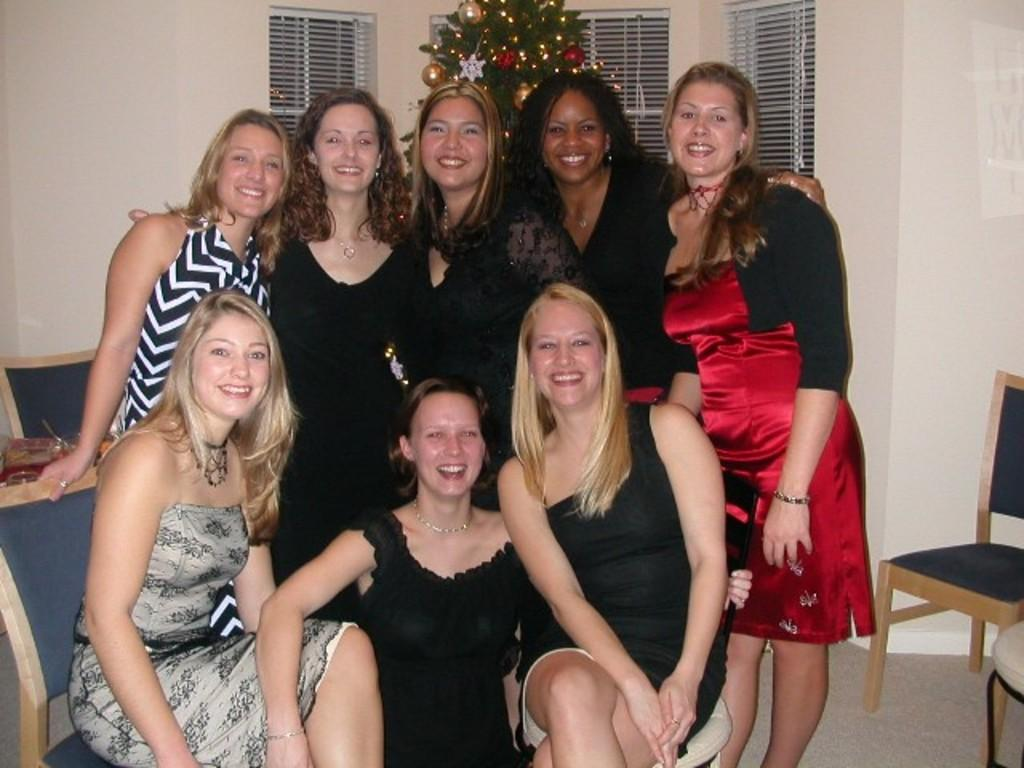What type of structure can be seen in the image? There is a wall in the image. Is there any opening in the wall? Yes, there is a window in the image. What is the occasion or theme of the image? There is a Christmas tree in the image, suggesting a holiday setting. Can you describe the people in the image? There are people standing and sitting in the image. What type of copper material is used to make the actor's costume in the image? There is no actor or copper material present in the image. What rule is being enforced by the people in the image? There is no indication of any rule being enforced in the image. 